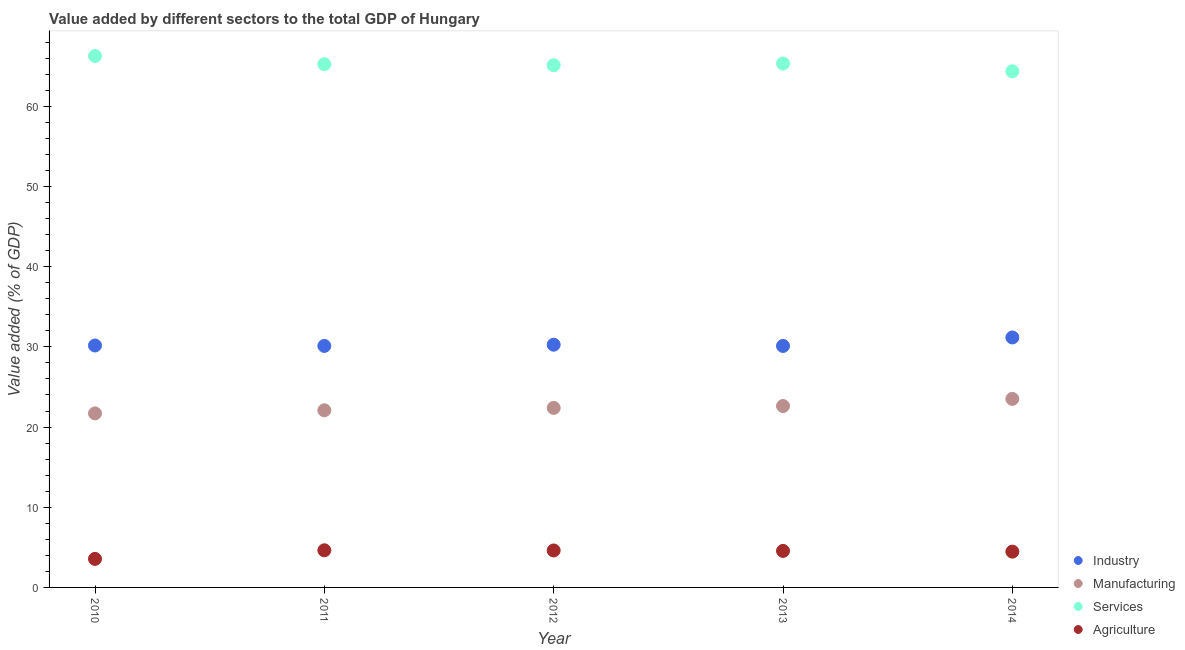Is the number of dotlines equal to the number of legend labels?
Offer a very short reply. Yes. What is the value added by services sector in 2011?
Offer a terse response. 65.25. Across all years, what is the maximum value added by industrial sector?
Offer a terse response. 31.17. Across all years, what is the minimum value added by manufacturing sector?
Provide a succinct answer. 21.7. In which year was the value added by services sector maximum?
Your answer should be compact. 2010. What is the total value added by manufacturing sector in the graph?
Provide a short and direct response. 112.31. What is the difference between the value added by industrial sector in 2010 and that in 2014?
Make the answer very short. -1. What is the difference between the value added by manufacturing sector in 2014 and the value added by industrial sector in 2013?
Provide a short and direct response. -6.6. What is the average value added by agricultural sector per year?
Make the answer very short. 4.36. In the year 2012, what is the difference between the value added by industrial sector and value added by services sector?
Offer a very short reply. -34.85. In how many years, is the value added by agricultural sector greater than 10 %?
Your answer should be very brief. 0. What is the ratio of the value added by manufacturing sector in 2011 to that in 2014?
Provide a succinct answer. 0.94. Is the value added by industrial sector in 2010 less than that in 2011?
Provide a short and direct response. No. What is the difference between the highest and the second highest value added by industrial sector?
Give a very brief answer. 0.9. What is the difference between the highest and the lowest value added by manufacturing sector?
Give a very brief answer. 1.81. In how many years, is the value added by manufacturing sector greater than the average value added by manufacturing sector taken over all years?
Your answer should be very brief. 2. Is it the case that in every year, the sum of the value added by services sector and value added by industrial sector is greater than the sum of value added by agricultural sector and value added by manufacturing sector?
Your response must be concise. No. Is it the case that in every year, the sum of the value added by industrial sector and value added by manufacturing sector is greater than the value added by services sector?
Your response must be concise. No. Does the value added by industrial sector monotonically increase over the years?
Make the answer very short. No. Is the value added by industrial sector strictly greater than the value added by agricultural sector over the years?
Your answer should be very brief. Yes. How many dotlines are there?
Give a very brief answer. 4. How many years are there in the graph?
Offer a terse response. 5. Does the graph contain any zero values?
Offer a very short reply. No. Does the graph contain grids?
Offer a very short reply. No. Where does the legend appear in the graph?
Provide a succinct answer. Bottom right. How are the legend labels stacked?
Provide a short and direct response. Vertical. What is the title of the graph?
Your answer should be very brief. Value added by different sectors to the total GDP of Hungary. What is the label or title of the Y-axis?
Your answer should be very brief. Value added (% of GDP). What is the Value added (% of GDP) in Industry in 2010?
Provide a short and direct response. 30.17. What is the Value added (% of GDP) of Manufacturing in 2010?
Offer a terse response. 21.7. What is the Value added (% of GDP) of Services in 2010?
Give a very brief answer. 66.27. What is the Value added (% of GDP) in Agriculture in 2010?
Keep it short and to the point. 3.56. What is the Value added (% of GDP) of Industry in 2011?
Make the answer very short. 30.12. What is the Value added (% of GDP) in Manufacturing in 2011?
Provide a succinct answer. 22.09. What is the Value added (% of GDP) in Services in 2011?
Give a very brief answer. 65.25. What is the Value added (% of GDP) of Agriculture in 2011?
Offer a terse response. 4.63. What is the Value added (% of GDP) of Industry in 2012?
Make the answer very short. 30.27. What is the Value added (% of GDP) of Manufacturing in 2012?
Keep it short and to the point. 22.39. What is the Value added (% of GDP) of Services in 2012?
Provide a succinct answer. 65.12. What is the Value added (% of GDP) of Agriculture in 2012?
Ensure brevity in your answer.  4.61. What is the Value added (% of GDP) in Industry in 2013?
Ensure brevity in your answer.  30.11. What is the Value added (% of GDP) of Manufacturing in 2013?
Give a very brief answer. 22.62. What is the Value added (% of GDP) in Services in 2013?
Offer a very short reply. 65.33. What is the Value added (% of GDP) of Agriculture in 2013?
Provide a short and direct response. 4.55. What is the Value added (% of GDP) of Industry in 2014?
Give a very brief answer. 31.17. What is the Value added (% of GDP) of Manufacturing in 2014?
Make the answer very short. 23.51. What is the Value added (% of GDP) of Services in 2014?
Provide a succinct answer. 64.36. What is the Value added (% of GDP) in Agriculture in 2014?
Your response must be concise. 4.46. Across all years, what is the maximum Value added (% of GDP) in Industry?
Ensure brevity in your answer.  31.17. Across all years, what is the maximum Value added (% of GDP) of Manufacturing?
Keep it short and to the point. 23.51. Across all years, what is the maximum Value added (% of GDP) in Services?
Keep it short and to the point. 66.27. Across all years, what is the maximum Value added (% of GDP) of Agriculture?
Your answer should be very brief. 4.63. Across all years, what is the minimum Value added (% of GDP) in Industry?
Your answer should be very brief. 30.11. Across all years, what is the minimum Value added (% of GDP) in Manufacturing?
Keep it short and to the point. 21.7. Across all years, what is the minimum Value added (% of GDP) of Services?
Your answer should be compact. 64.36. Across all years, what is the minimum Value added (% of GDP) of Agriculture?
Make the answer very short. 3.56. What is the total Value added (% of GDP) in Industry in the graph?
Keep it short and to the point. 151.84. What is the total Value added (% of GDP) of Manufacturing in the graph?
Provide a short and direct response. 112.31. What is the total Value added (% of GDP) of Services in the graph?
Your answer should be compact. 326.34. What is the total Value added (% of GDP) in Agriculture in the graph?
Your response must be concise. 21.82. What is the difference between the Value added (% of GDP) of Industry in 2010 and that in 2011?
Provide a short and direct response. 0.05. What is the difference between the Value added (% of GDP) in Manufacturing in 2010 and that in 2011?
Offer a terse response. -0.39. What is the difference between the Value added (% of GDP) of Services in 2010 and that in 2011?
Provide a short and direct response. 1.02. What is the difference between the Value added (% of GDP) in Agriculture in 2010 and that in 2011?
Provide a succinct answer. -1.07. What is the difference between the Value added (% of GDP) of Industry in 2010 and that in 2012?
Your answer should be compact. -0.1. What is the difference between the Value added (% of GDP) in Manufacturing in 2010 and that in 2012?
Ensure brevity in your answer.  -0.68. What is the difference between the Value added (% of GDP) of Services in 2010 and that in 2012?
Give a very brief answer. 1.15. What is the difference between the Value added (% of GDP) in Agriculture in 2010 and that in 2012?
Your response must be concise. -1.05. What is the difference between the Value added (% of GDP) of Industry in 2010 and that in 2013?
Offer a very short reply. 0.05. What is the difference between the Value added (% of GDP) of Manufacturing in 2010 and that in 2013?
Keep it short and to the point. -0.92. What is the difference between the Value added (% of GDP) in Services in 2010 and that in 2013?
Provide a short and direct response. 0.94. What is the difference between the Value added (% of GDP) of Agriculture in 2010 and that in 2013?
Ensure brevity in your answer.  -1. What is the difference between the Value added (% of GDP) in Industry in 2010 and that in 2014?
Provide a succinct answer. -1. What is the difference between the Value added (% of GDP) in Manufacturing in 2010 and that in 2014?
Your answer should be compact. -1.81. What is the difference between the Value added (% of GDP) in Services in 2010 and that in 2014?
Offer a terse response. 1.91. What is the difference between the Value added (% of GDP) of Agriculture in 2010 and that in 2014?
Your answer should be compact. -0.91. What is the difference between the Value added (% of GDP) in Industry in 2011 and that in 2012?
Make the answer very short. -0.15. What is the difference between the Value added (% of GDP) of Manufacturing in 2011 and that in 2012?
Your answer should be very brief. -0.3. What is the difference between the Value added (% of GDP) in Services in 2011 and that in 2012?
Provide a short and direct response. 0.13. What is the difference between the Value added (% of GDP) of Agriculture in 2011 and that in 2012?
Your answer should be compact. 0.02. What is the difference between the Value added (% of GDP) in Industry in 2011 and that in 2013?
Provide a short and direct response. 0. What is the difference between the Value added (% of GDP) of Manufacturing in 2011 and that in 2013?
Ensure brevity in your answer.  -0.53. What is the difference between the Value added (% of GDP) in Services in 2011 and that in 2013?
Offer a terse response. -0.08. What is the difference between the Value added (% of GDP) in Agriculture in 2011 and that in 2013?
Ensure brevity in your answer.  0.08. What is the difference between the Value added (% of GDP) in Industry in 2011 and that in 2014?
Give a very brief answer. -1.05. What is the difference between the Value added (% of GDP) in Manufacturing in 2011 and that in 2014?
Your answer should be very brief. -1.42. What is the difference between the Value added (% of GDP) of Services in 2011 and that in 2014?
Offer a very short reply. 0.89. What is the difference between the Value added (% of GDP) of Agriculture in 2011 and that in 2014?
Offer a terse response. 0.17. What is the difference between the Value added (% of GDP) of Industry in 2012 and that in 2013?
Your response must be concise. 0.15. What is the difference between the Value added (% of GDP) in Manufacturing in 2012 and that in 2013?
Provide a short and direct response. -0.23. What is the difference between the Value added (% of GDP) of Services in 2012 and that in 2013?
Your answer should be compact. -0.21. What is the difference between the Value added (% of GDP) of Agriculture in 2012 and that in 2013?
Your response must be concise. 0.06. What is the difference between the Value added (% of GDP) of Industry in 2012 and that in 2014?
Keep it short and to the point. -0.9. What is the difference between the Value added (% of GDP) of Manufacturing in 2012 and that in 2014?
Your response must be concise. -1.12. What is the difference between the Value added (% of GDP) in Services in 2012 and that in 2014?
Keep it short and to the point. 0.76. What is the difference between the Value added (% of GDP) of Agriculture in 2012 and that in 2014?
Your answer should be compact. 0.14. What is the difference between the Value added (% of GDP) in Industry in 2013 and that in 2014?
Make the answer very short. -1.06. What is the difference between the Value added (% of GDP) of Manufacturing in 2013 and that in 2014?
Give a very brief answer. -0.89. What is the difference between the Value added (% of GDP) of Agriculture in 2013 and that in 2014?
Your answer should be compact. 0.09. What is the difference between the Value added (% of GDP) in Industry in 2010 and the Value added (% of GDP) in Manufacturing in 2011?
Provide a succinct answer. 8.08. What is the difference between the Value added (% of GDP) of Industry in 2010 and the Value added (% of GDP) of Services in 2011?
Your response must be concise. -35.08. What is the difference between the Value added (% of GDP) of Industry in 2010 and the Value added (% of GDP) of Agriculture in 2011?
Offer a very short reply. 25.54. What is the difference between the Value added (% of GDP) of Manufacturing in 2010 and the Value added (% of GDP) of Services in 2011?
Provide a short and direct response. -43.55. What is the difference between the Value added (% of GDP) in Manufacturing in 2010 and the Value added (% of GDP) in Agriculture in 2011?
Provide a short and direct response. 17.07. What is the difference between the Value added (% of GDP) in Services in 2010 and the Value added (% of GDP) in Agriculture in 2011?
Keep it short and to the point. 61.64. What is the difference between the Value added (% of GDP) of Industry in 2010 and the Value added (% of GDP) of Manufacturing in 2012?
Give a very brief answer. 7.78. What is the difference between the Value added (% of GDP) of Industry in 2010 and the Value added (% of GDP) of Services in 2012?
Your answer should be compact. -34.95. What is the difference between the Value added (% of GDP) in Industry in 2010 and the Value added (% of GDP) in Agriculture in 2012?
Offer a terse response. 25.56. What is the difference between the Value added (% of GDP) in Manufacturing in 2010 and the Value added (% of GDP) in Services in 2012?
Make the answer very short. -43.42. What is the difference between the Value added (% of GDP) in Manufacturing in 2010 and the Value added (% of GDP) in Agriculture in 2012?
Provide a short and direct response. 17.09. What is the difference between the Value added (% of GDP) of Services in 2010 and the Value added (% of GDP) of Agriculture in 2012?
Offer a very short reply. 61.67. What is the difference between the Value added (% of GDP) in Industry in 2010 and the Value added (% of GDP) in Manufacturing in 2013?
Give a very brief answer. 7.55. What is the difference between the Value added (% of GDP) in Industry in 2010 and the Value added (% of GDP) in Services in 2013?
Keep it short and to the point. -35.16. What is the difference between the Value added (% of GDP) in Industry in 2010 and the Value added (% of GDP) in Agriculture in 2013?
Your answer should be very brief. 25.61. What is the difference between the Value added (% of GDP) in Manufacturing in 2010 and the Value added (% of GDP) in Services in 2013?
Keep it short and to the point. -43.63. What is the difference between the Value added (% of GDP) in Manufacturing in 2010 and the Value added (% of GDP) in Agriculture in 2013?
Give a very brief answer. 17.15. What is the difference between the Value added (% of GDP) in Services in 2010 and the Value added (% of GDP) in Agriculture in 2013?
Your answer should be very brief. 61.72. What is the difference between the Value added (% of GDP) of Industry in 2010 and the Value added (% of GDP) of Manufacturing in 2014?
Offer a very short reply. 6.66. What is the difference between the Value added (% of GDP) in Industry in 2010 and the Value added (% of GDP) in Services in 2014?
Your answer should be compact. -34.2. What is the difference between the Value added (% of GDP) in Industry in 2010 and the Value added (% of GDP) in Agriculture in 2014?
Your response must be concise. 25.7. What is the difference between the Value added (% of GDP) of Manufacturing in 2010 and the Value added (% of GDP) of Services in 2014?
Make the answer very short. -42.66. What is the difference between the Value added (% of GDP) in Manufacturing in 2010 and the Value added (% of GDP) in Agriculture in 2014?
Your answer should be compact. 17.24. What is the difference between the Value added (% of GDP) in Services in 2010 and the Value added (% of GDP) in Agriculture in 2014?
Your response must be concise. 61.81. What is the difference between the Value added (% of GDP) of Industry in 2011 and the Value added (% of GDP) of Manufacturing in 2012?
Your answer should be very brief. 7.73. What is the difference between the Value added (% of GDP) in Industry in 2011 and the Value added (% of GDP) in Services in 2012?
Your answer should be very brief. -35. What is the difference between the Value added (% of GDP) in Industry in 2011 and the Value added (% of GDP) in Agriculture in 2012?
Ensure brevity in your answer.  25.51. What is the difference between the Value added (% of GDP) in Manufacturing in 2011 and the Value added (% of GDP) in Services in 2012?
Provide a succinct answer. -43.03. What is the difference between the Value added (% of GDP) in Manufacturing in 2011 and the Value added (% of GDP) in Agriculture in 2012?
Your answer should be very brief. 17.48. What is the difference between the Value added (% of GDP) of Services in 2011 and the Value added (% of GDP) of Agriculture in 2012?
Offer a very short reply. 60.64. What is the difference between the Value added (% of GDP) in Industry in 2011 and the Value added (% of GDP) in Manufacturing in 2013?
Your answer should be compact. 7.5. What is the difference between the Value added (% of GDP) of Industry in 2011 and the Value added (% of GDP) of Services in 2013?
Provide a succinct answer. -35.21. What is the difference between the Value added (% of GDP) in Industry in 2011 and the Value added (% of GDP) in Agriculture in 2013?
Provide a short and direct response. 25.56. What is the difference between the Value added (% of GDP) in Manufacturing in 2011 and the Value added (% of GDP) in Services in 2013?
Give a very brief answer. -43.24. What is the difference between the Value added (% of GDP) of Manufacturing in 2011 and the Value added (% of GDP) of Agriculture in 2013?
Provide a succinct answer. 17.54. What is the difference between the Value added (% of GDP) of Services in 2011 and the Value added (% of GDP) of Agriculture in 2013?
Make the answer very short. 60.7. What is the difference between the Value added (% of GDP) in Industry in 2011 and the Value added (% of GDP) in Manufacturing in 2014?
Give a very brief answer. 6.61. What is the difference between the Value added (% of GDP) in Industry in 2011 and the Value added (% of GDP) in Services in 2014?
Keep it short and to the point. -34.25. What is the difference between the Value added (% of GDP) of Industry in 2011 and the Value added (% of GDP) of Agriculture in 2014?
Give a very brief answer. 25.65. What is the difference between the Value added (% of GDP) of Manufacturing in 2011 and the Value added (% of GDP) of Services in 2014?
Give a very brief answer. -42.27. What is the difference between the Value added (% of GDP) of Manufacturing in 2011 and the Value added (% of GDP) of Agriculture in 2014?
Give a very brief answer. 17.63. What is the difference between the Value added (% of GDP) in Services in 2011 and the Value added (% of GDP) in Agriculture in 2014?
Keep it short and to the point. 60.79. What is the difference between the Value added (% of GDP) of Industry in 2012 and the Value added (% of GDP) of Manufacturing in 2013?
Offer a very short reply. 7.65. What is the difference between the Value added (% of GDP) of Industry in 2012 and the Value added (% of GDP) of Services in 2013?
Offer a very short reply. -35.06. What is the difference between the Value added (% of GDP) of Industry in 2012 and the Value added (% of GDP) of Agriculture in 2013?
Keep it short and to the point. 25.72. What is the difference between the Value added (% of GDP) in Manufacturing in 2012 and the Value added (% of GDP) in Services in 2013?
Keep it short and to the point. -42.95. What is the difference between the Value added (% of GDP) of Manufacturing in 2012 and the Value added (% of GDP) of Agriculture in 2013?
Your answer should be compact. 17.83. What is the difference between the Value added (% of GDP) of Services in 2012 and the Value added (% of GDP) of Agriculture in 2013?
Provide a short and direct response. 60.57. What is the difference between the Value added (% of GDP) of Industry in 2012 and the Value added (% of GDP) of Manufacturing in 2014?
Offer a very short reply. 6.76. What is the difference between the Value added (% of GDP) in Industry in 2012 and the Value added (% of GDP) in Services in 2014?
Offer a terse response. -34.1. What is the difference between the Value added (% of GDP) of Industry in 2012 and the Value added (% of GDP) of Agriculture in 2014?
Your answer should be compact. 25.81. What is the difference between the Value added (% of GDP) in Manufacturing in 2012 and the Value added (% of GDP) in Services in 2014?
Offer a very short reply. -41.98. What is the difference between the Value added (% of GDP) of Manufacturing in 2012 and the Value added (% of GDP) of Agriculture in 2014?
Make the answer very short. 17.92. What is the difference between the Value added (% of GDP) of Services in 2012 and the Value added (% of GDP) of Agriculture in 2014?
Offer a terse response. 60.66. What is the difference between the Value added (% of GDP) in Industry in 2013 and the Value added (% of GDP) in Manufacturing in 2014?
Offer a very short reply. 6.6. What is the difference between the Value added (% of GDP) in Industry in 2013 and the Value added (% of GDP) in Services in 2014?
Ensure brevity in your answer.  -34.25. What is the difference between the Value added (% of GDP) in Industry in 2013 and the Value added (% of GDP) in Agriculture in 2014?
Provide a short and direct response. 25.65. What is the difference between the Value added (% of GDP) of Manufacturing in 2013 and the Value added (% of GDP) of Services in 2014?
Keep it short and to the point. -41.74. What is the difference between the Value added (% of GDP) in Manufacturing in 2013 and the Value added (% of GDP) in Agriculture in 2014?
Offer a very short reply. 18.16. What is the difference between the Value added (% of GDP) in Services in 2013 and the Value added (% of GDP) in Agriculture in 2014?
Offer a terse response. 60.87. What is the average Value added (% of GDP) of Industry per year?
Ensure brevity in your answer.  30.37. What is the average Value added (% of GDP) of Manufacturing per year?
Your answer should be very brief. 22.46. What is the average Value added (% of GDP) of Services per year?
Provide a succinct answer. 65.27. What is the average Value added (% of GDP) in Agriculture per year?
Offer a terse response. 4.36. In the year 2010, what is the difference between the Value added (% of GDP) in Industry and Value added (% of GDP) in Manufacturing?
Offer a terse response. 8.47. In the year 2010, what is the difference between the Value added (% of GDP) in Industry and Value added (% of GDP) in Services?
Give a very brief answer. -36.11. In the year 2010, what is the difference between the Value added (% of GDP) of Industry and Value added (% of GDP) of Agriculture?
Offer a terse response. 26.61. In the year 2010, what is the difference between the Value added (% of GDP) of Manufacturing and Value added (% of GDP) of Services?
Keep it short and to the point. -44.57. In the year 2010, what is the difference between the Value added (% of GDP) in Manufacturing and Value added (% of GDP) in Agriculture?
Provide a succinct answer. 18.14. In the year 2010, what is the difference between the Value added (% of GDP) of Services and Value added (% of GDP) of Agriculture?
Ensure brevity in your answer.  62.72. In the year 2011, what is the difference between the Value added (% of GDP) in Industry and Value added (% of GDP) in Manufacturing?
Make the answer very short. 8.03. In the year 2011, what is the difference between the Value added (% of GDP) in Industry and Value added (% of GDP) in Services?
Your answer should be very brief. -35.13. In the year 2011, what is the difference between the Value added (% of GDP) of Industry and Value added (% of GDP) of Agriculture?
Keep it short and to the point. 25.49. In the year 2011, what is the difference between the Value added (% of GDP) in Manufacturing and Value added (% of GDP) in Services?
Provide a succinct answer. -43.16. In the year 2011, what is the difference between the Value added (% of GDP) in Manufacturing and Value added (% of GDP) in Agriculture?
Your answer should be very brief. 17.46. In the year 2011, what is the difference between the Value added (% of GDP) in Services and Value added (% of GDP) in Agriculture?
Offer a terse response. 60.62. In the year 2012, what is the difference between the Value added (% of GDP) in Industry and Value added (% of GDP) in Manufacturing?
Offer a terse response. 7.88. In the year 2012, what is the difference between the Value added (% of GDP) of Industry and Value added (% of GDP) of Services?
Give a very brief answer. -34.85. In the year 2012, what is the difference between the Value added (% of GDP) of Industry and Value added (% of GDP) of Agriculture?
Offer a very short reply. 25.66. In the year 2012, what is the difference between the Value added (% of GDP) in Manufacturing and Value added (% of GDP) in Services?
Your response must be concise. -42.74. In the year 2012, what is the difference between the Value added (% of GDP) of Manufacturing and Value added (% of GDP) of Agriculture?
Your answer should be very brief. 17.78. In the year 2012, what is the difference between the Value added (% of GDP) of Services and Value added (% of GDP) of Agriculture?
Offer a very short reply. 60.51. In the year 2013, what is the difference between the Value added (% of GDP) of Industry and Value added (% of GDP) of Manufacturing?
Offer a very short reply. 7.5. In the year 2013, what is the difference between the Value added (% of GDP) in Industry and Value added (% of GDP) in Services?
Your response must be concise. -35.22. In the year 2013, what is the difference between the Value added (% of GDP) in Industry and Value added (% of GDP) in Agriculture?
Provide a short and direct response. 25.56. In the year 2013, what is the difference between the Value added (% of GDP) of Manufacturing and Value added (% of GDP) of Services?
Provide a succinct answer. -42.71. In the year 2013, what is the difference between the Value added (% of GDP) in Manufacturing and Value added (% of GDP) in Agriculture?
Provide a short and direct response. 18.07. In the year 2013, what is the difference between the Value added (% of GDP) in Services and Value added (% of GDP) in Agriculture?
Your response must be concise. 60.78. In the year 2014, what is the difference between the Value added (% of GDP) of Industry and Value added (% of GDP) of Manufacturing?
Offer a very short reply. 7.66. In the year 2014, what is the difference between the Value added (% of GDP) of Industry and Value added (% of GDP) of Services?
Keep it short and to the point. -33.19. In the year 2014, what is the difference between the Value added (% of GDP) in Industry and Value added (% of GDP) in Agriculture?
Provide a succinct answer. 26.71. In the year 2014, what is the difference between the Value added (% of GDP) of Manufacturing and Value added (% of GDP) of Services?
Your response must be concise. -40.85. In the year 2014, what is the difference between the Value added (% of GDP) of Manufacturing and Value added (% of GDP) of Agriculture?
Your response must be concise. 19.05. In the year 2014, what is the difference between the Value added (% of GDP) in Services and Value added (% of GDP) in Agriculture?
Offer a very short reply. 59.9. What is the ratio of the Value added (% of GDP) in Manufacturing in 2010 to that in 2011?
Offer a very short reply. 0.98. What is the ratio of the Value added (% of GDP) of Services in 2010 to that in 2011?
Your answer should be compact. 1.02. What is the ratio of the Value added (% of GDP) in Agriculture in 2010 to that in 2011?
Offer a very short reply. 0.77. What is the ratio of the Value added (% of GDP) in Industry in 2010 to that in 2012?
Keep it short and to the point. 1. What is the ratio of the Value added (% of GDP) in Manufacturing in 2010 to that in 2012?
Provide a succinct answer. 0.97. What is the ratio of the Value added (% of GDP) of Services in 2010 to that in 2012?
Make the answer very short. 1.02. What is the ratio of the Value added (% of GDP) of Agriculture in 2010 to that in 2012?
Your answer should be very brief. 0.77. What is the ratio of the Value added (% of GDP) in Industry in 2010 to that in 2013?
Ensure brevity in your answer.  1. What is the ratio of the Value added (% of GDP) of Manufacturing in 2010 to that in 2013?
Make the answer very short. 0.96. What is the ratio of the Value added (% of GDP) in Services in 2010 to that in 2013?
Provide a short and direct response. 1.01. What is the ratio of the Value added (% of GDP) in Agriculture in 2010 to that in 2013?
Offer a terse response. 0.78. What is the ratio of the Value added (% of GDP) of Industry in 2010 to that in 2014?
Your answer should be very brief. 0.97. What is the ratio of the Value added (% of GDP) of Services in 2010 to that in 2014?
Make the answer very short. 1.03. What is the ratio of the Value added (% of GDP) of Agriculture in 2010 to that in 2014?
Make the answer very short. 0.8. What is the ratio of the Value added (% of GDP) in Manufacturing in 2011 to that in 2012?
Offer a very short reply. 0.99. What is the ratio of the Value added (% of GDP) in Services in 2011 to that in 2012?
Keep it short and to the point. 1. What is the ratio of the Value added (% of GDP) in Agriculture in 2011 to that in 2012?
Provide a succinct answer. 1.01. What is the ratio of the Value added (% of GDP) in Manufacturing in 2011 to that in 2013?
Ensure brevity in your answer.  0.98. What is the ratio of the Value added (% of GDP) of Agriculture in 2011 to that in 2013?
Make the answer very short. 1.02. What is the ratio of the Value added (% of GDP) of Industry in 2011 to that in 2014?
Give a very brief answer. 0.97. What is the ratio of the Value added (% of GDP) in Manufacturing in 2011 to that in 2014?
Ensure brevity in your answer.  0.94. What is the ratio of the Value added (% of GDP) of Services in 2011 to that in 2014?
Your response must be concise. 1.01. What is the ratio of the Value added (% of GDP) of Agriculture in 2011 to that in 2014?
Your answer should be very brief. 1.04. What is the ratio of the Value added (% of GDP) in Services in 2012 to that in 2013?
Your response must be concise. 1. What is the ratio of the Value added (% of GDP) in Agriculture in 2012 to that in 2013?
Your answer should be very brief. 1.01. What is the ratio of the Value added (% of GDP) of Industry in 2012 to that in 2014?
Make the answer very short. 0.97. What is the ratio of the Value added (% of GDP) in Manufacturing in 2012 to that in 2014?
Provide a succinct answer. 0.95. What is the ratio of the Value added (% of GDP) in Services in 2012 to that in 2014?
Provide a short and direct response. 1.01. What is the ratio of the Value added (% of GDP) in Agriculture in 2012 to that in 2014?
Your answer should be very brief. 1.03. What is the ratio of the Value added (% of GDP) in Industry in 2013 to that in 2014?
Offer a very short reply. 0.97. What is the ratio of the Value added (% of GDP) in Manufacturing in 2013 to that in 2014?
Offer a very short reply. 0.96. What is the ratio of the Value added (% of GDP) in Agriculture in 2013 to that in 2014?
Give a very brief answer. 1.02. What is the difference between the highest and the second highest Value added (% of GDP) in Industry?
Keep it short and to the point. 0.9. What is the difference between the highest and the second highest Value added (% of GDP) in Manufacturing?
Make the answer very short. 0.89. What is the difference between the highest and the second highest Value added (% of GDP) of Services?
Give a very brief answer. 0.94. What is the difference between the highest and the second highest Value added (% of GDP) of Agriculture?
Make the answer very short. 0.02. What is the difference between the highest and the lowest Value added (% of GDP) in Industry?
Your response must be concise. 1.06. What is the difference between the highest and the lowest Value added (% of GDP) of Manufacturing?
Offer a very short reply. 1.81. What is the difference between the highest and the lowest Value added (% of GDP) of Services?
Your answer should be compact. 1.91. What is the difference between the highest and the lowest Value added (% of GDP) of Agriculture?
Offer a terse response. 1.07. 